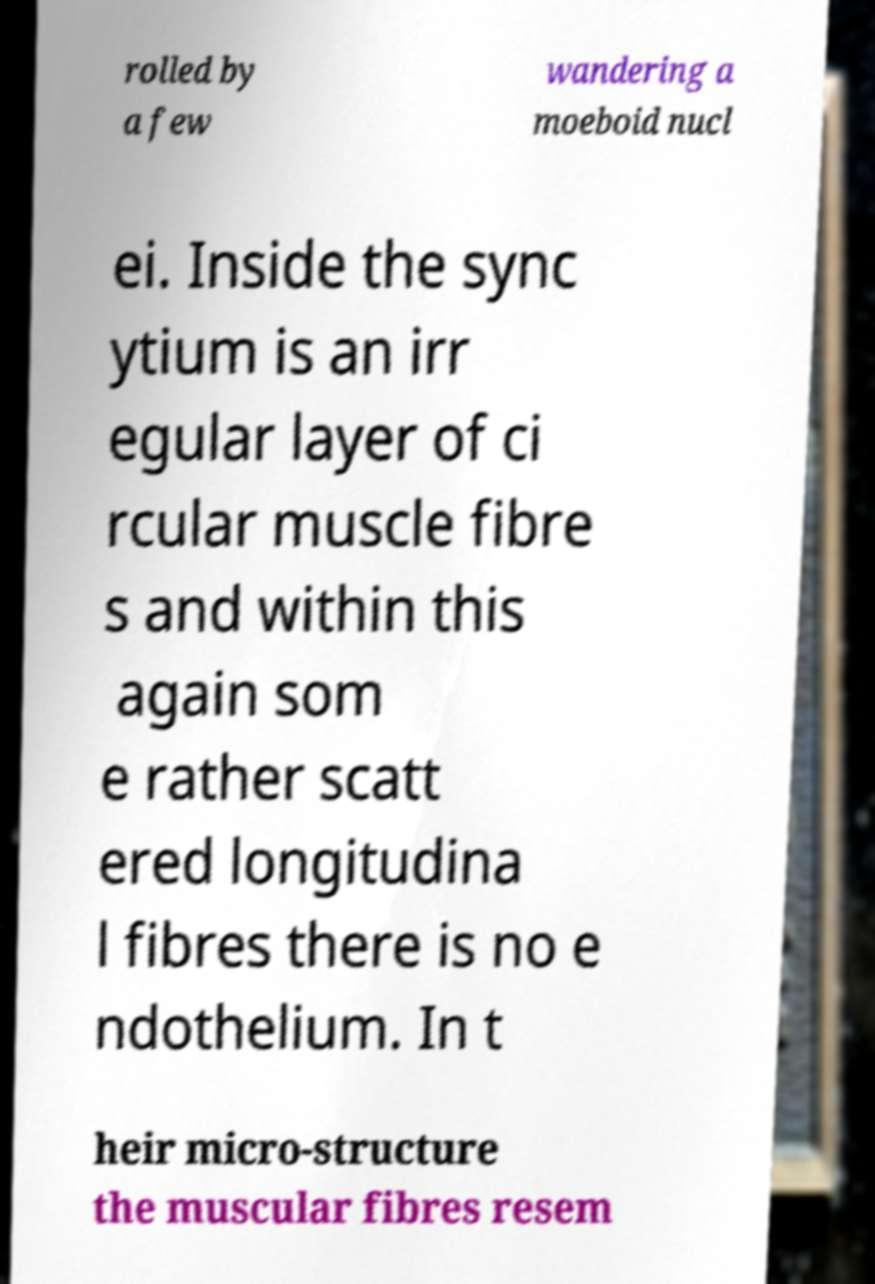Could you assist in decoding the text presented in this image and type it out clearly? rolled by a few wandering a moeboid nucl ei. Inside the sync ytium is an irr egular layer of ci rcular muscle fibre s and within this again som e rather scatt ered longitudina l fibres there is no e ndothelium. In t heir micro-structure the muscular fibres resem 